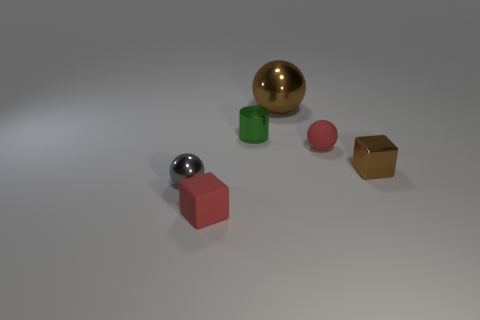Is there any pattern or theme to the arrangement of these objects? There doesn't appear to be a discernible pattern or theme in how the objects are arranged. They seem to be placed randomly on the surface with varying distances between them, suggesting no intentional pattern or thematic relationship. 